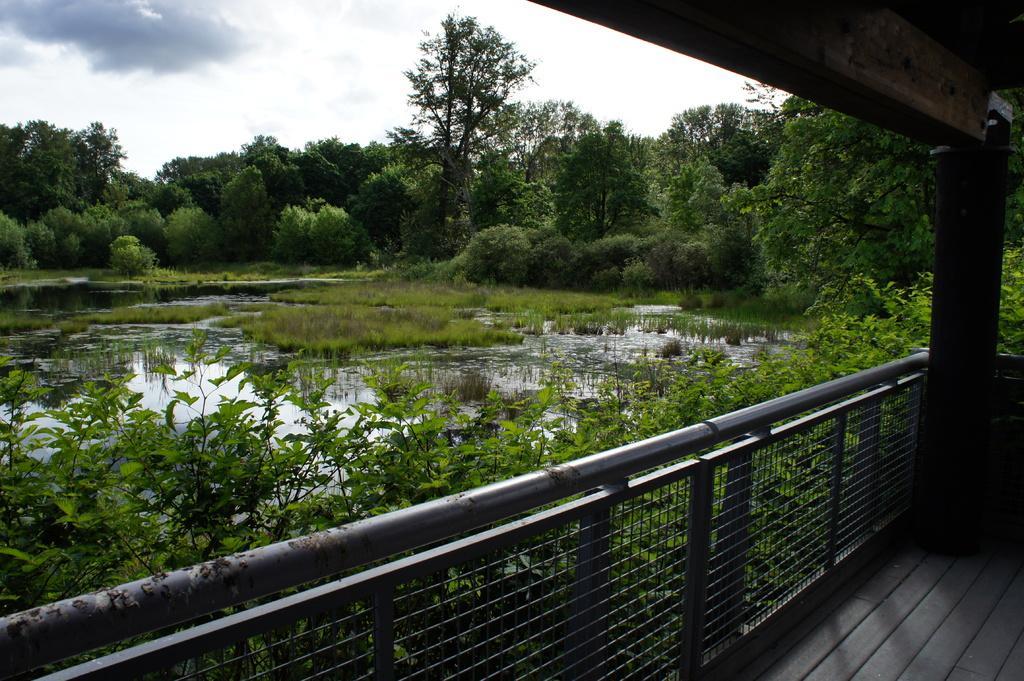Describe this image in one or two sentences. In this picture we can see many trees, plants and grass. On the right there is a wooden pillar, beside that we can see the steel fencing. On the left we can see the water. At the top we can see sky and clouds. In the bottom right corner there is a wooden floor. 